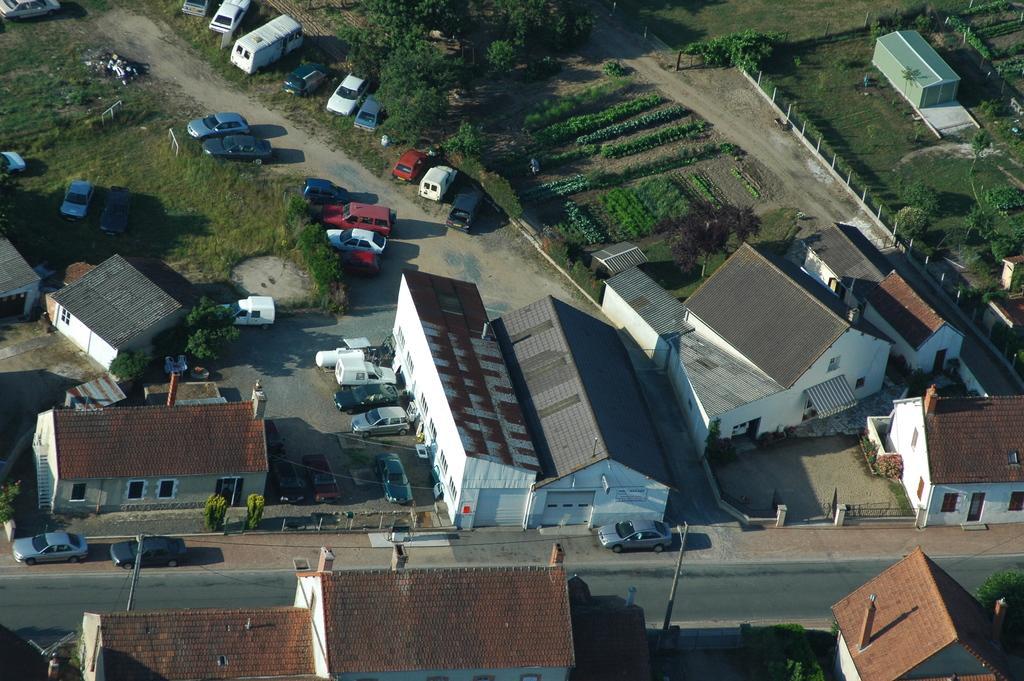Can you describe this image briefly? In this image there are houses, there are houses truncated towards the bottom of the image, there is road truncated, there are poles, there are houses truncated towards the right of the image, there is a house truncated towards the left of the image, there are vehicles, there are plants, there is the grass, there are plants truncated towards the right of the image, there are plants truncated towards the top of the image, there are vehicles truncated towards the top of the image, there are vehicles truncated towards the left of the image, there are trees, there is the door, there are windows, there is a wall. 